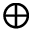Convert formula to latex. <formula><loc_0><loc_0><loc_500><loc_500>\oplus</formula> 